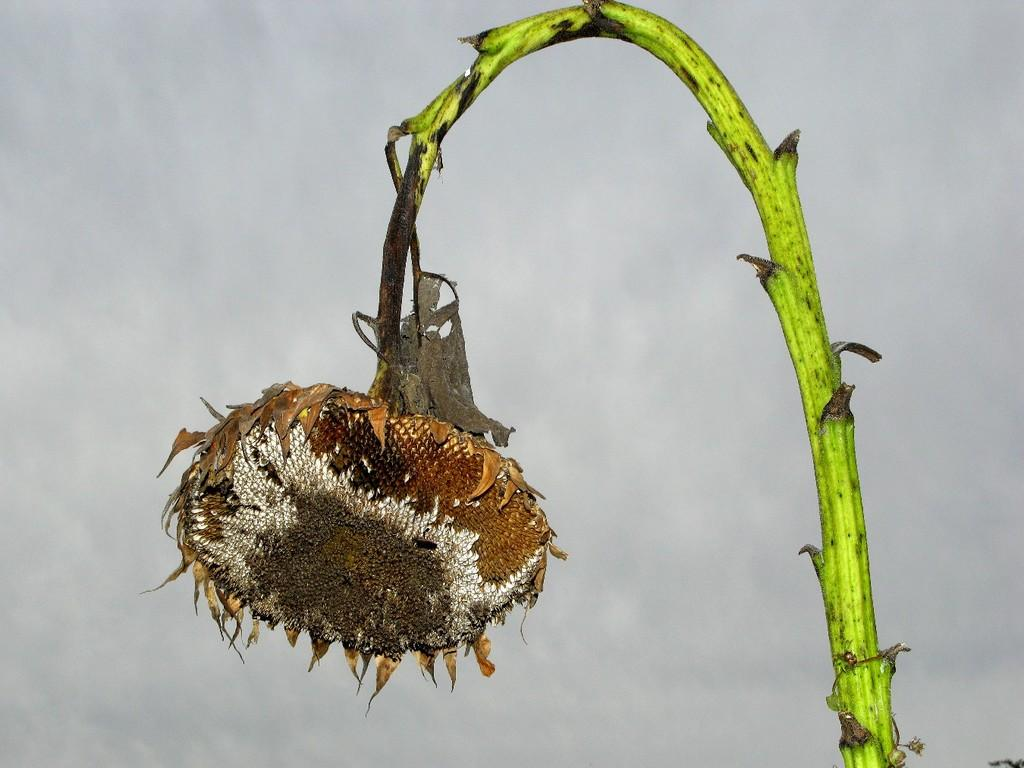What type of plant is in the image? There is a sunflower in the image. What color is the stem of the sunflower? The sunflower has a green stem. What can be seen at the top of the image? The sky is visible at the top of the image. Can you tell me how many geese are playing chess on the string in the image? There are no geese, chess, or string present in the image. 